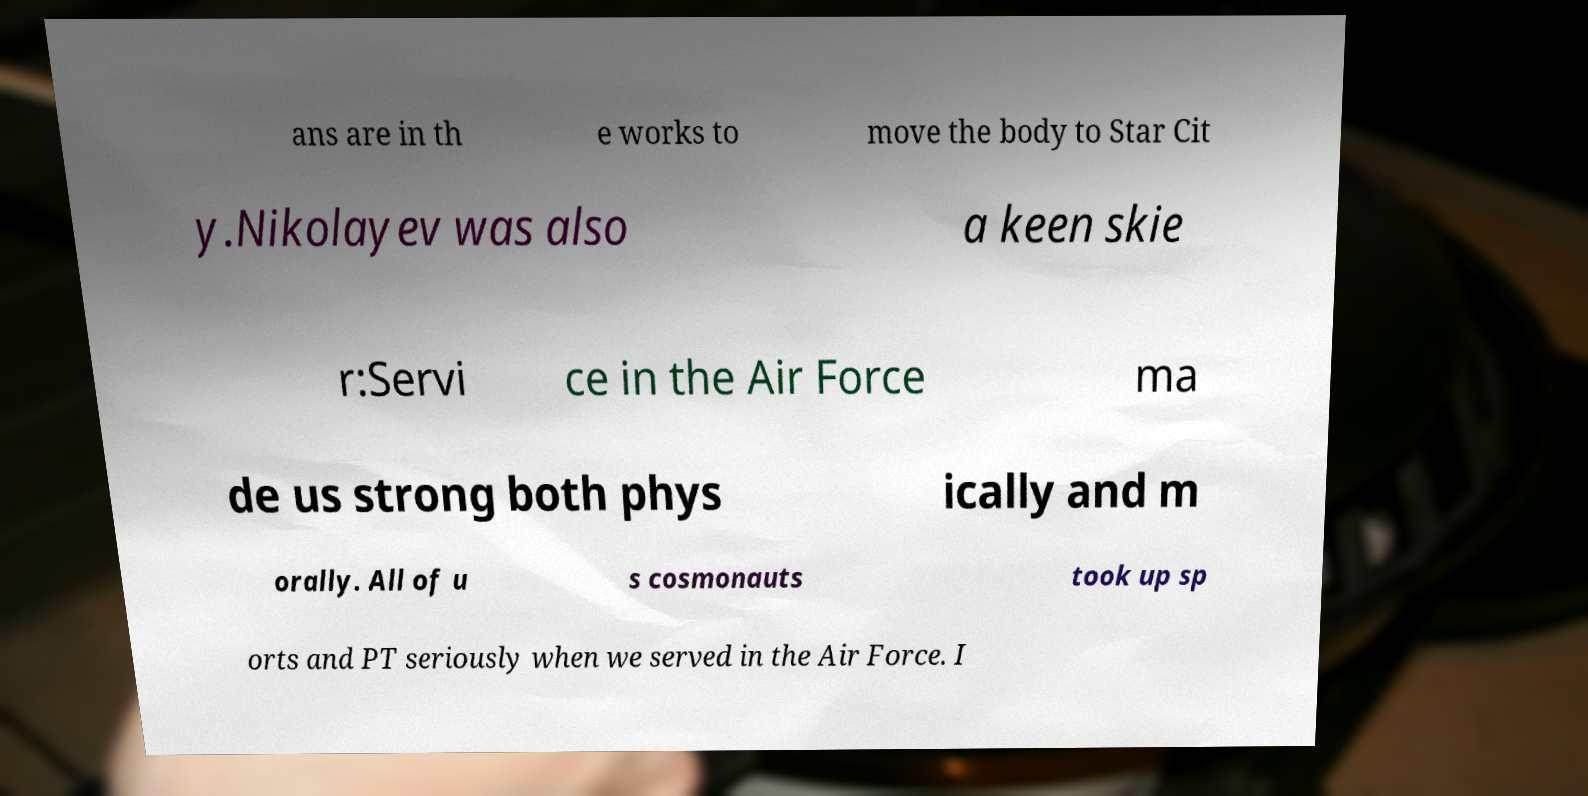Please read and relay the text visible in this image. What does it say? ans are in th e works to move the body to Star Cit y.Nikolayev was also a keen skie r:Servi ce in the Air Force ma de us strong both phys ically and m orally. All of u s cosmonauts took up sp orts and PT seriously when we served in the Air Force. I 